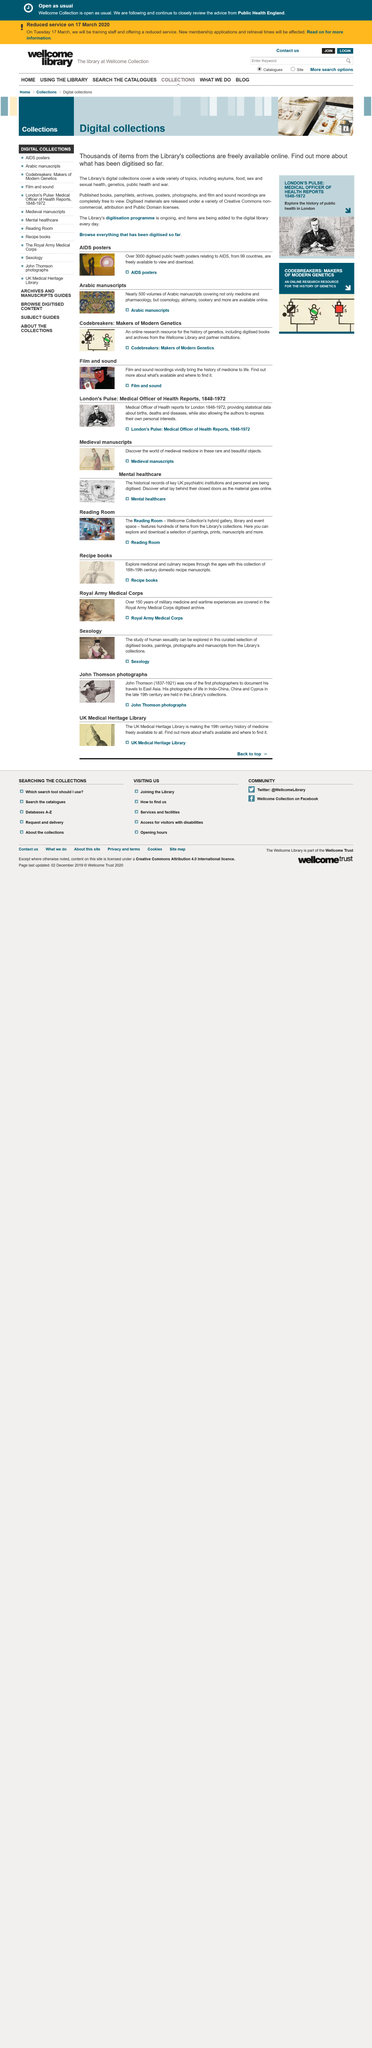Identify some key points in this picture. A significant number of items from the Library can be accessed online, with over a thousand items available in this format. The digitization program is still in progress. Yes, published books are completely free to view. 